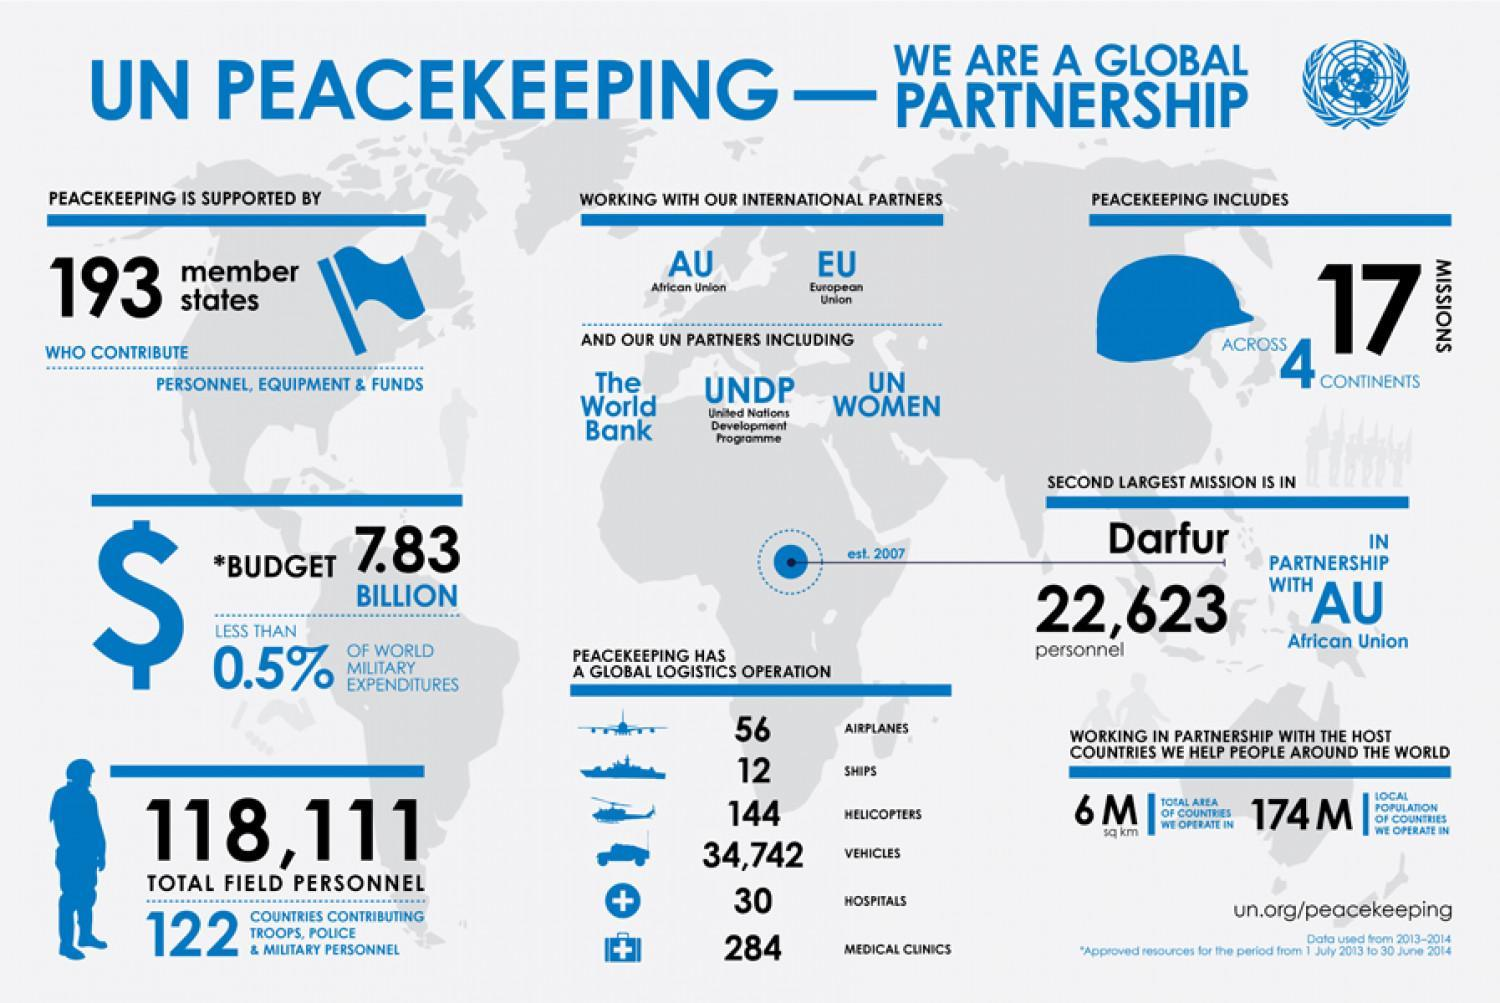How many member states contributed to the UN peacekeeping operations?
Answer the question with a short phrase. 193 What is the total budget for the UN peacekeeping operations in dollars? 7.83 BILLION How many missions were carried out by the UN peacekeepers across different continents? 17 MISSIONS In which region, the second largest mission by the UN peacekeeping operated? Darfur How many personnels were deployed in the Darfur mission by the UN in 2007? 22,623 